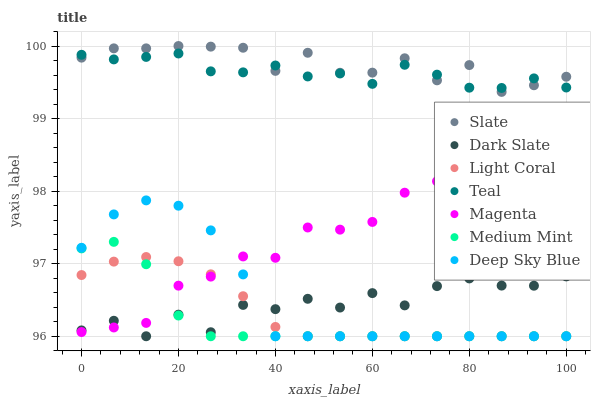Does Medium Mint have the minimum area under the curve?
Answer yes or no. Yes. Does Slate have the maximum area under the curve?
Answer yes or no. Yes. Does Deep Sky Blue have the minimum area under the curve?
Answer yes or no. No. Does Deep Sky Blue have the maximum area under the curve?
Answer yes or no. No. Is Light Coral the smoothest?
Answer yes or no. Yes. Is Dark Slate the roughest?
Answer yes or no. Yes. Is Deep Sky Blue the smoothest?
Answer yes or no. No. Is Deep Sky Blue the roughest?
Answer yes or no. No. Does Medium Mint have the lowest value?
Answer yes or no. Yes. Does Slate have the lowest value?
Answer yes or no. No. Does Slate have the highest value?
Answer yes or no. Yes. Does Deep Sky Blue have the highest value?
Answer yes or no. No. Is Deep Sky Blue less than Teal?
Answer yes or no. Yes. Is Slate greater than Deep Sky Blue?
Answer yes or no. Yes. Does Deep Sky Blue intersect Magenta?
Answer yes or no. Yes. Is Deep Sky Blue less than Magenta?
Answer yes or no. No. Is Deep Sky Blue greater than Magenta?
Answer yes or no. No. Does Deep Sky Blue intersect Teal?
Answer yes or no. No. 